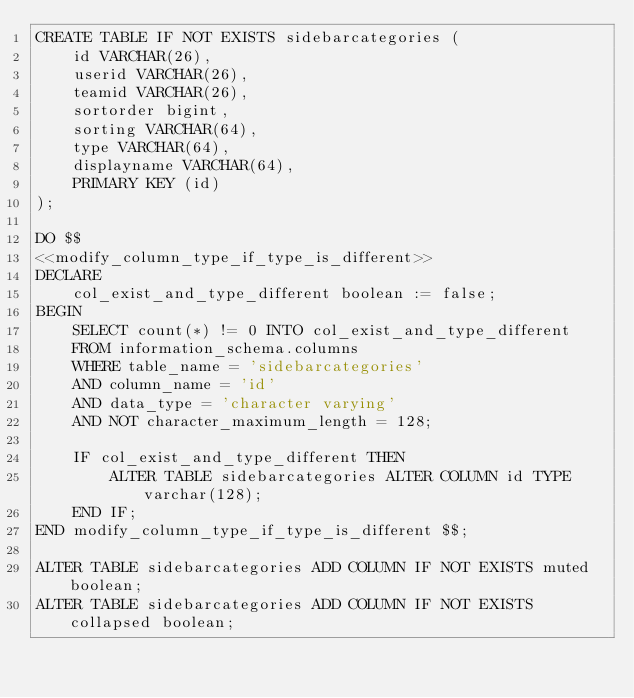<code> <loc_0><loc_0><loc_500><loc_500><_SQL_>CREATE TABLE IF NOT EXISTS sidebarcategories (
    id VARCHAR(26),
    userid VARCHAR(26),
    teamid VARCHAR(26),
    sortorder bigint,
    sorting VARCHAR(64),
    type VARCHAR(64),
    displayname VARCHAR(64),
    PRIMARY KEY (id)
);

DO $$
<<modify_column_type_if_type_is_different>>
DECLARE
    col_exist_and_type_different boolean := false;
BEGIN
    SELECT count(*) != 0 INTO col_exist_and_type_different
    FROM information_schema.columns
    WHERE table_name = 'sidebarcategories'
    AND column_name = 'id'
    AND data_type = 'character varying'
    AND NOT character_maximum_length = 128;

    IF col_exist_and_type_different THEN
        ALTER TABLE sidebarcategories ALTER COLUMN id TYPE varchar(128);
    END IF;
END modify_column_type_if_type_is_different $$;

ALTER TABLE sidebarcategories ADD COLUMN IF NOT EXISTS muted boolean;
ALTER TABLE sidebarcategories ADD COLUMN IF NOT EXISTS collapsed boolean;
</code> 